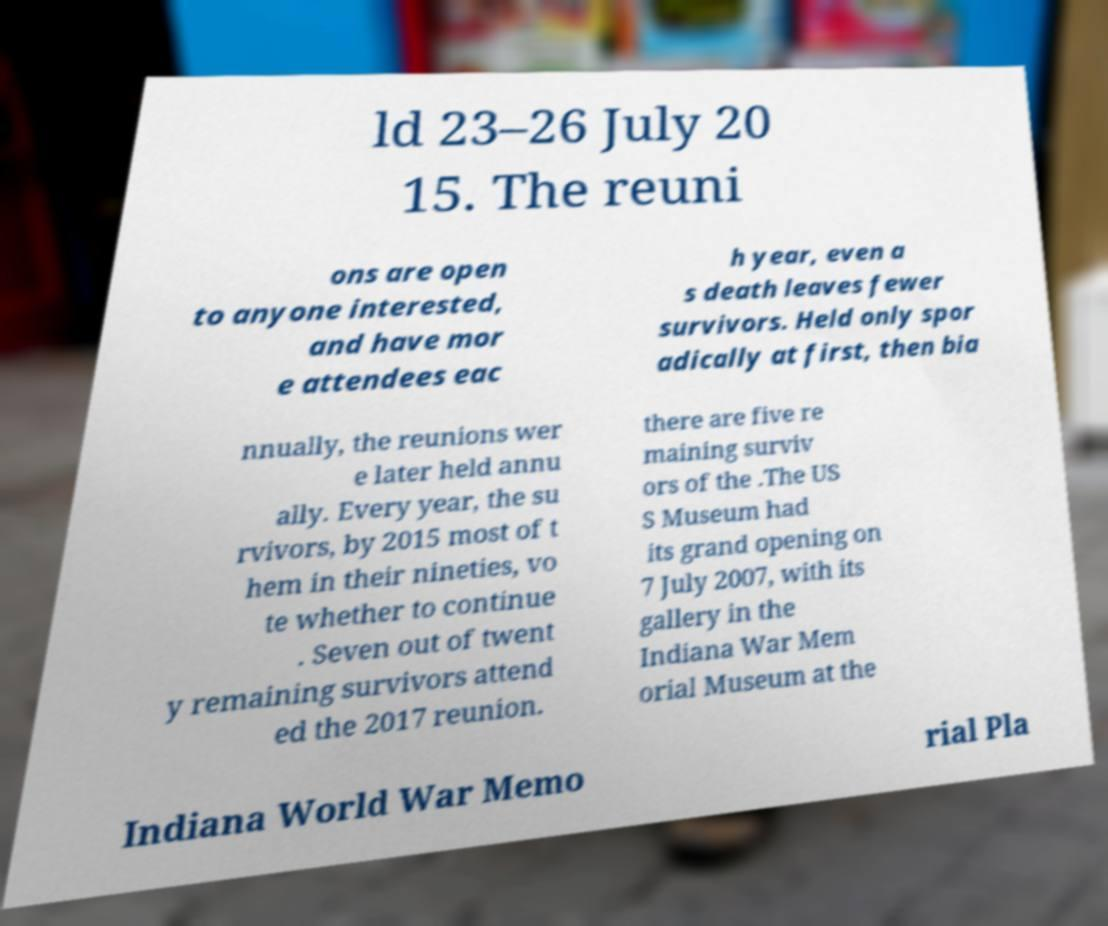Please identify and transcribe the text found in this image. ld 23–26 July 20 15. The reuni ons are open to anyone interested, and have mor e attendees eac h year, even a s death leaves fewer survivors. Held only spor adically at first, then bia nnually, the reunions wer e later held annu ally. Every year, the su rvivors, by 2015 most of t hem in their nineties, vo te whether to continue . Seven out of twent y remaining survivors attend ed the 2017 reunion. there are five re maining surviv ors of the .The US S Museum had its grand opening on 7 July 2007, with its gallery in the Indiana War Mem orial Museum at the Indiana World War Memo rial Pla 